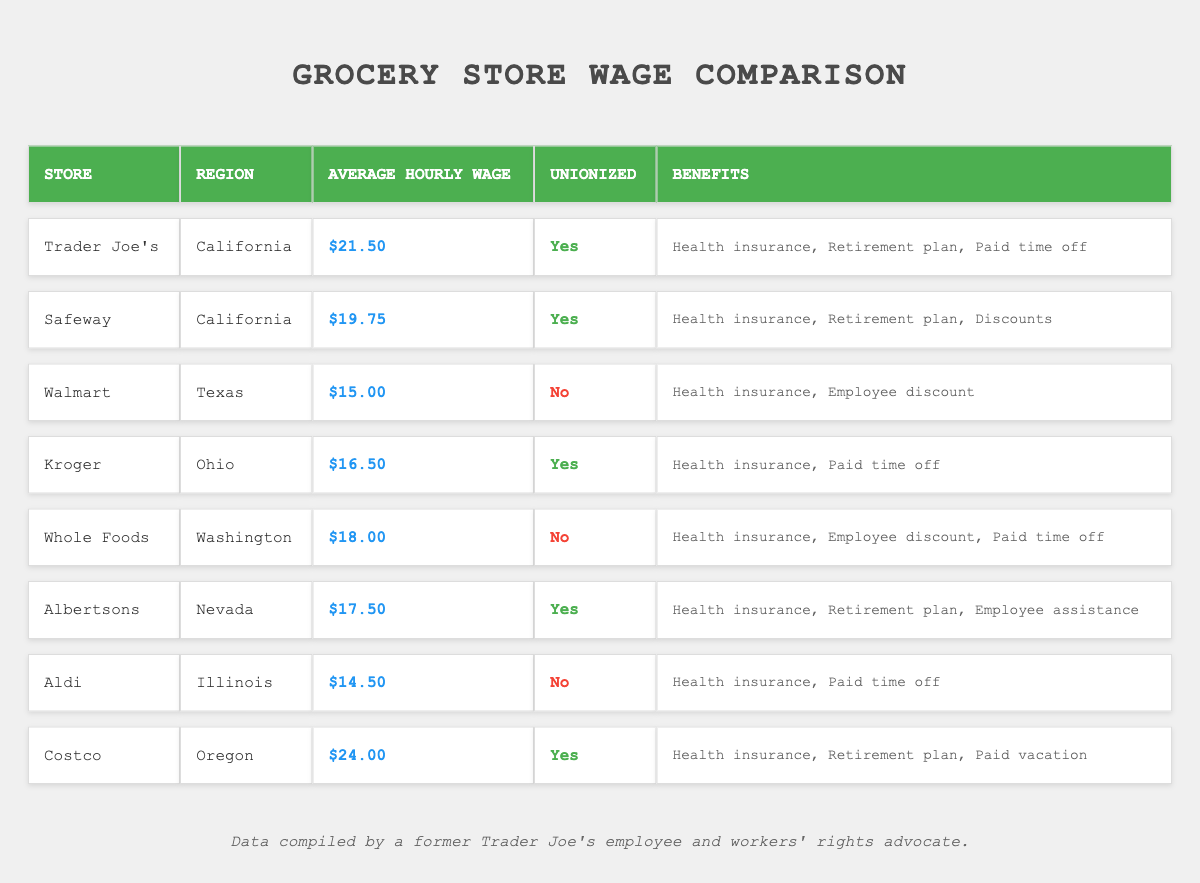What is the highest average hourly wage among the grocery stores listed? By examining the 'Average Hourly Wage' column, the highest wage is found under 'Costco,' which is $24.00.
Answer: $24.00 Which store has the lowest average hourly wage? From the 'Average Hourly Wage' column, 'Aldi' shows the lowest average wage, which is $14.50.
Answer: $14.50 How many stores listed are unionized? Reading the 'Unionized' column, 'Trader Joe's,' 'Safeway,' 'Kroger,' 'Albertsons,' and 'Costco' are marked as unionized for a total of 5 stores.
Answer: 5 What is the average hourly wage for unionized stores? The average wage can be calculated by summing the wages of the unionized stores: $21.50 + $19.75 + $16.50 + $17.50 + $24.00 = $99.25. There are 5 unionized stores, so the average is $99.25 / 5 = $19.85.
Answer: $19.85 Do all the stores provide health insurance as a benefit? Checking the benefits listed, all stores except for 'Aldi' and 'Whole Foods' offer health insurance, which indicates that not all stores provide it.
Answer: No Which region has the highest average hourly wage, and what is it? The 'Average Hourly Wage' indicates that 'Costco' in 'Oregon' has the highest wage at $24.00, indicating that Oregon has the highest average wage among the regions listed.
Answer: Oregon, $24.00 Is there a store in Texas that offers a higher average hourly wage than $20? The table lists 'Walmart' in Texas with an average hourly wage of $15.00, which is below $20. Thus, there are no Texas stores offering above $20.
Answer: No How much more does Costco pay compared to Aldi? 'Costco' pays $24.00 per hour and 'Aldi' pays $14.50 per hour. The difference is $24.00 - $14.50 = $9.50.
Answer: $9.50 What percentage of the stores listed are non-unionized? There are 3 non-unionized stores: 'Walmart,' 'Whole Foods,' and 'Aldi' out of 8 total stores. The percentage is (3/8) * 100 = 37.5%.
Answer: 37.5% If we only consider the unionized stores, which one has the lowest wage? Among the unionized stores, 'Kroger' has the lowest average wage at $16.50, confirmed by comparing the wages of the unionized entries.
Answer: $16.50 